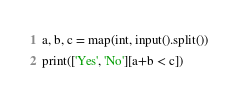Convert code to text. <code><loc_0><loc_0><loc_500><loc_500><_Python_>a, b, c = map(int, input().split())
print(['Yes', 'No'][a+b < c])</code> 